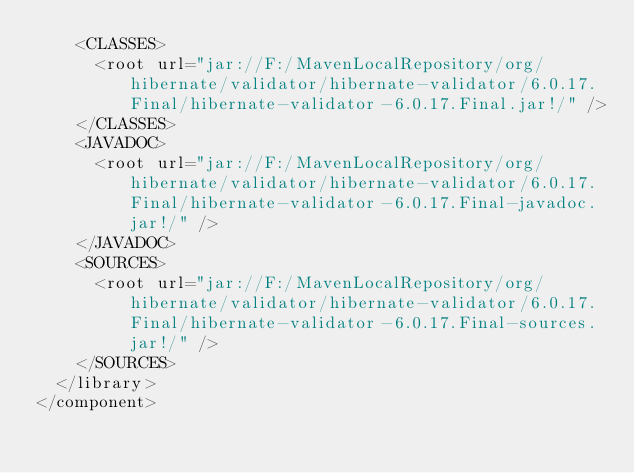Convert code to text. <code><loc_0><loc_0><loc_500><loc_500><_XML_>    <CLASSES>
      <root url="jar://F:/MavenLocalRepository/org/hibernate/validator/hibernate-validator/6.0.17.Final/hibernate-validator-6.0.17.Final.jar!/" />
    </CLASSES>
    <JAVADOC>
      <root url="jar://F:/MavenLocalRepository/org/hibernate/validator/hibernate-validator/6.0.17.Final/hibernate-validator-6.0.17.Final-javadoc.jar!/" />
    </JAVADOC>
    <SOURCES>
      <root url="jar://F:/MavenLocalRepository/org/hibernate/validator/hibernate-validator/6.0.17.Final/hibernate-validator-6.0.17.Final-sources.jar!/" />
    </SOURCES>
  </library>
</component></code> 